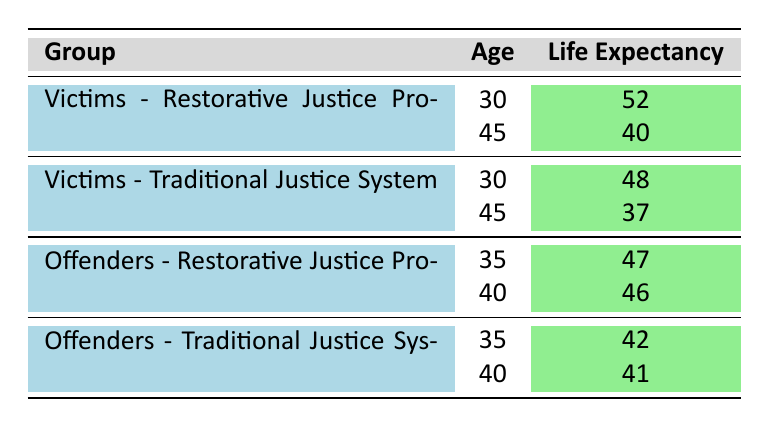What's the life expectancy of victims who are Restorative Justice Program Participants at age 30? According to the table, the life expectancy for this group is specified under the corresponding row for age 30. It shows 52 years.
Answer: 52 What's the difference in life expectancy between victims in the Traditional Justice System and those in the Restorative Justice Program at age 45? The life expectancy for victims in the Traditional Justice System at age 45 is 37 years, while for those in the Restorative Justice Program, it is 40 years. The difference is 40 - 37 = 3 years.
Answer: 3 years Do offenders who participate in the Restorative Justice Program generally have a higher life expectancy than those in the Traditional Justice System? For offenders at age 35, the life expectancy in the Restorative Justice Program is 47 years, whereas in the Traditional Justice System, it is 42 years. Therefore, it is true that they have a higher life expectancy.
Answer: Yes What is the average life expectancy for victims across both justice systems at age 30? For victims at age 30, the life expectancies are 52 (Restorative Justice Program) and 48 (Traditional Justice System). Summing these gives 52 + 48 = 100. The average is 100 / 2 = 50 years.
Answer: 50 years At age 40, how much longer do Offenders in the Restorative Justice Program expect to live compared to those in the Traditional Justice System? The life expectancy of offenders in the Restorative Justice Program at age 40 is 46 years, while in the Traditional Justice System it is 41 years. The difference is 46 - 41 = 5 years longer.
Answer: 5 years longer Is the life expectancy of victims in the Traditional Justice System at age 45 less than that of offenders in the same system at age 35? The life expectancy of victims in the Traditional Justice System at age 45 is 37 years. For offenders in the same system at age 35, it is 42 years. Since 37 is less than 42, the statement is true.
Answer: Yes How does life expectancy change for Restorative Justice Program Participants from age 30 to age 45 for victims? The life expectancy decreases from 52 years at age 30 to 40 years at age 45. Thus, the change is 52 - 40 = 12 years decrease.
Answer: 12 years decrease 